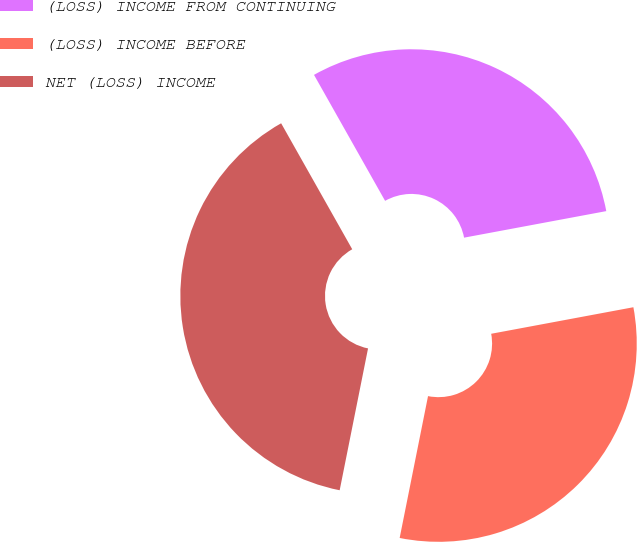Convert chart to OTSL. <chart><loc_0><loc_0><loc_500><loc_500><pie_chart><fcel>(LOSS) INCOME FROM CONTINUING<fcel>(LOSS) INCOME BEFORE<fcel>NET (LOSS) INCOME<nl><fcel>30.24%<fcel>31.08%<fcel>38.68%<nl></chart> 